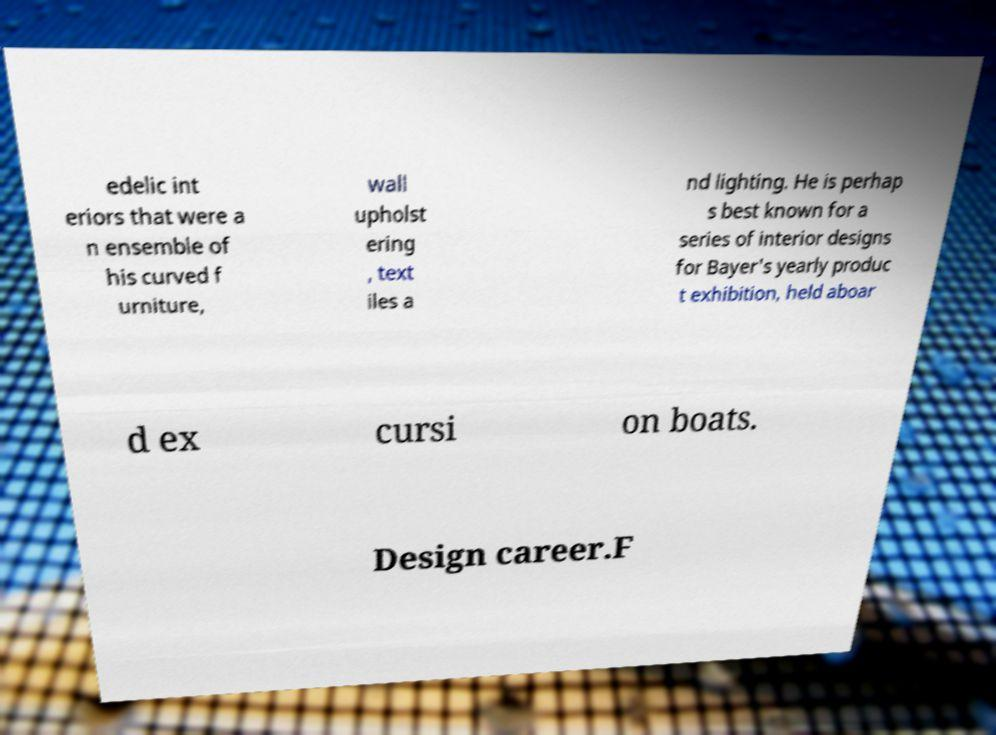Could you extract and type out the text from this image? edelic int eriors that were a n ensemble of his curved f urniture, wall upholst ering , text iles a nd lighting. He is perhap s best known for a series of interior designs for Bayer's yearly produc t exhibition, held aboar d ex cursi on boats. Design career.F 